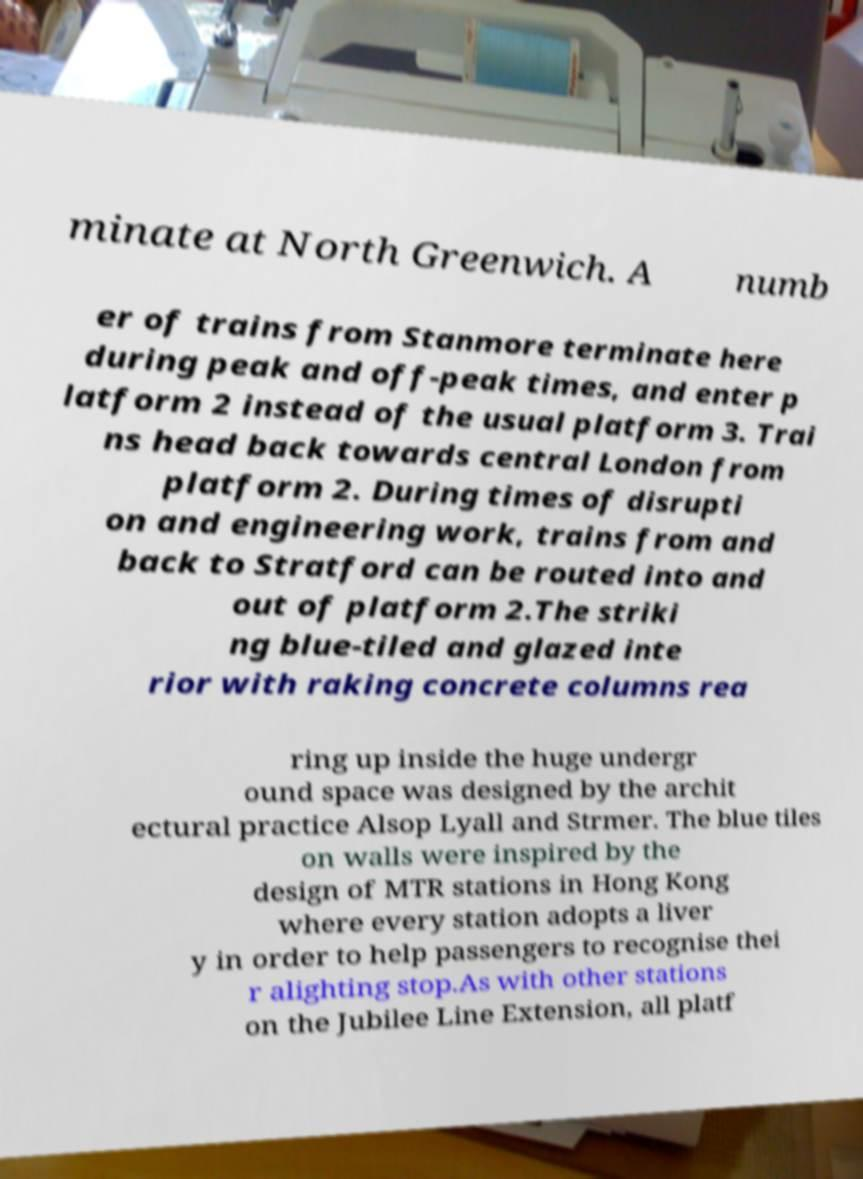There's text embedded in this image that I need extracted. Can you transcribe it verbatim? minate at North Greenwich. A numb er of trains from Stanmore terminate here during peak and off-peak times, and enter p latform 2 instead of the usual platform 3. Trai ns head back towards central London from platform 2. During times of disrupti on and engineering work, trains from and back to Stratford can be routed into and out of platform 2.The striki ng blue-tiled and glazed inte rior with raking concrete columns rea ring up inside the huge undergr ound space was designed by the archit ectural practice Alsop Lyall and Strmer. The blue tiles on walls were inspired by the design of MTR stations in Hong Kong where every station adopts a liver y in order to help passengers to recognise thei r alighting stop.As with other stations on the Jubilee Line Extension, all platf 